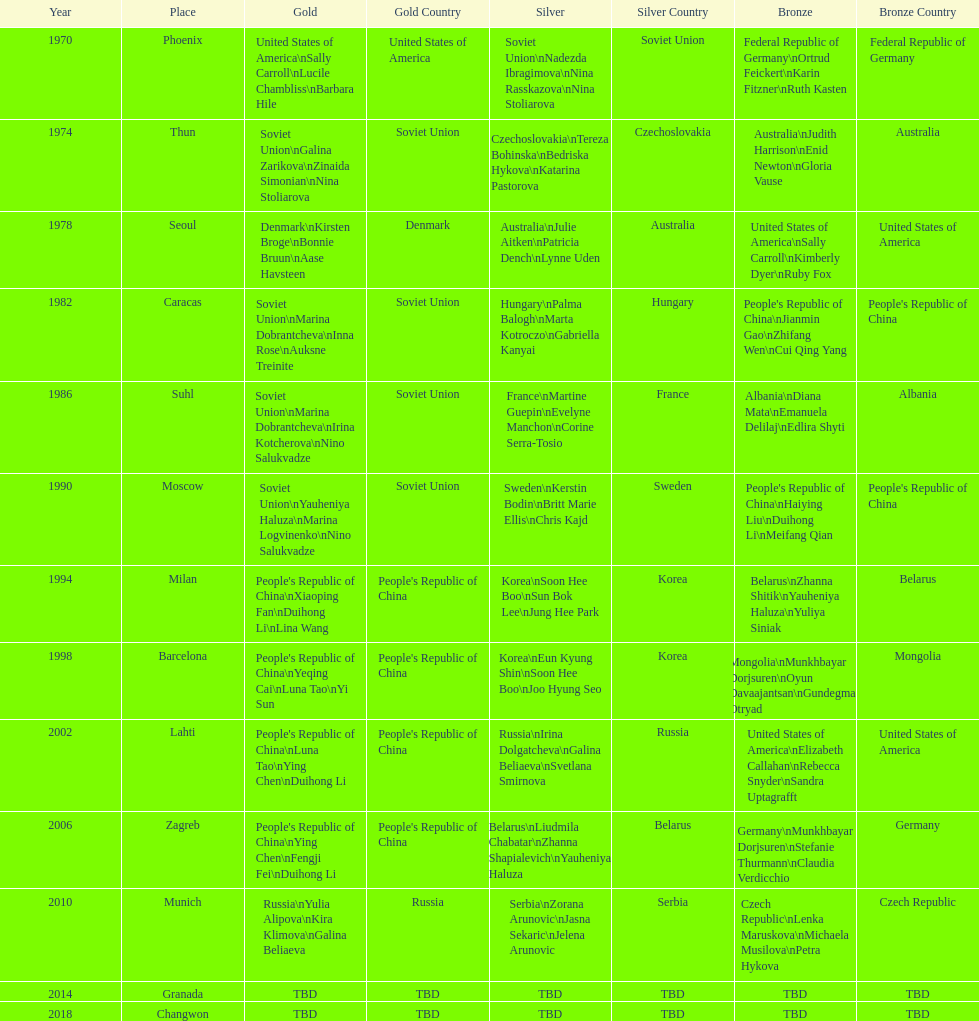What are the total number of times the soviet union is listed under the gold column? 4. 